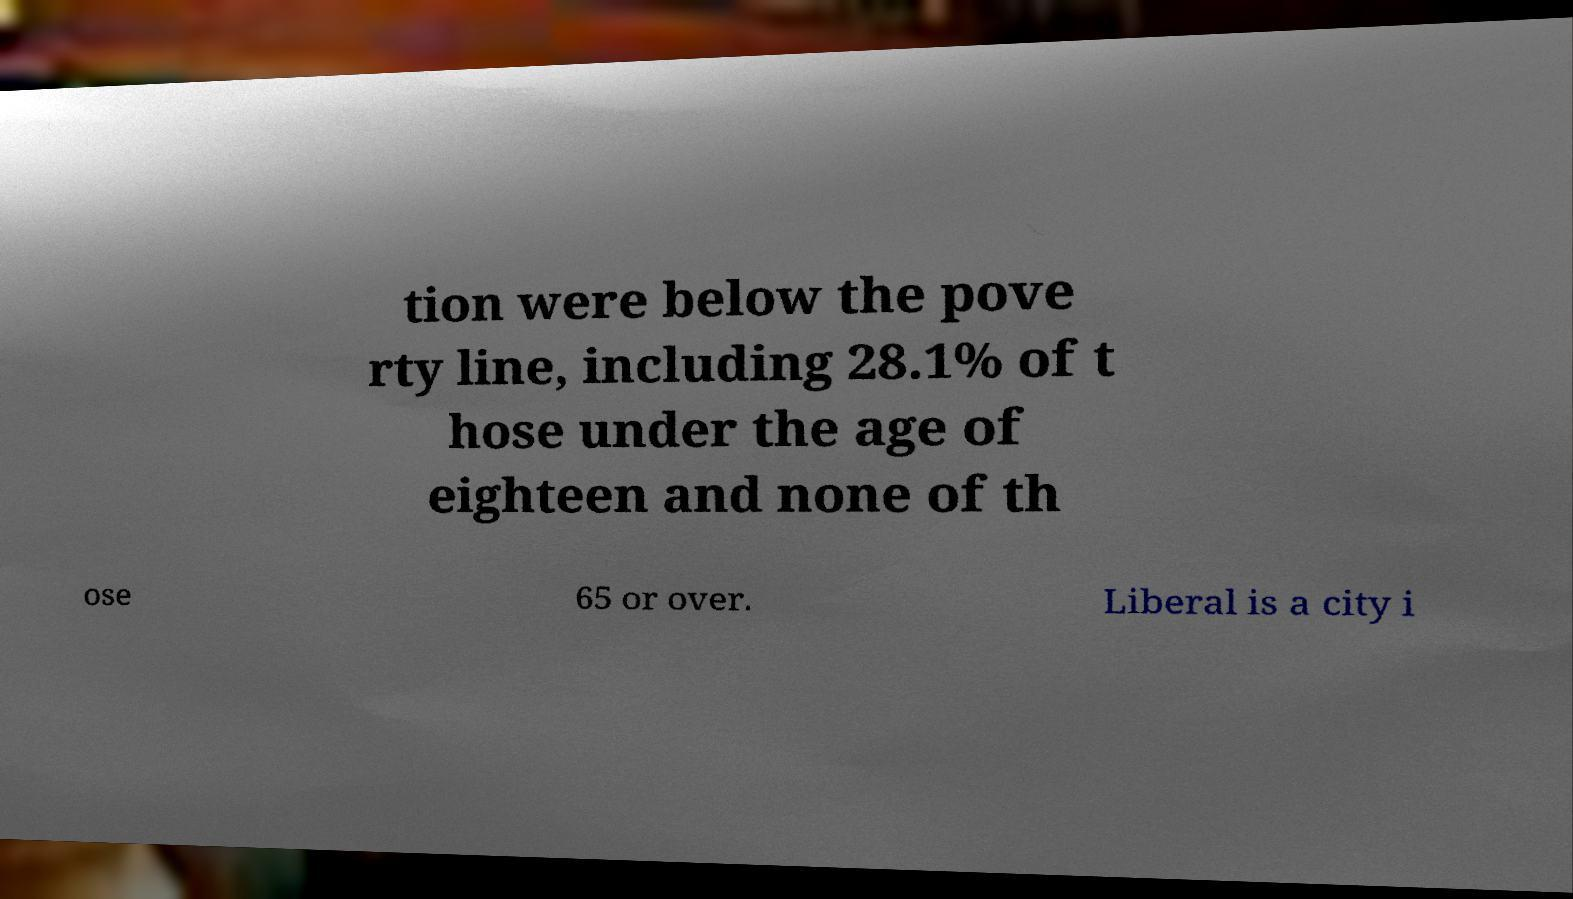For documentation purposes, I need the text within this image transcribed. Could you provide that? tion were below the pove rty line, including 28.1% of t hose under the age of eighteen and none of th ose 65 or over. Liberal is a city i 